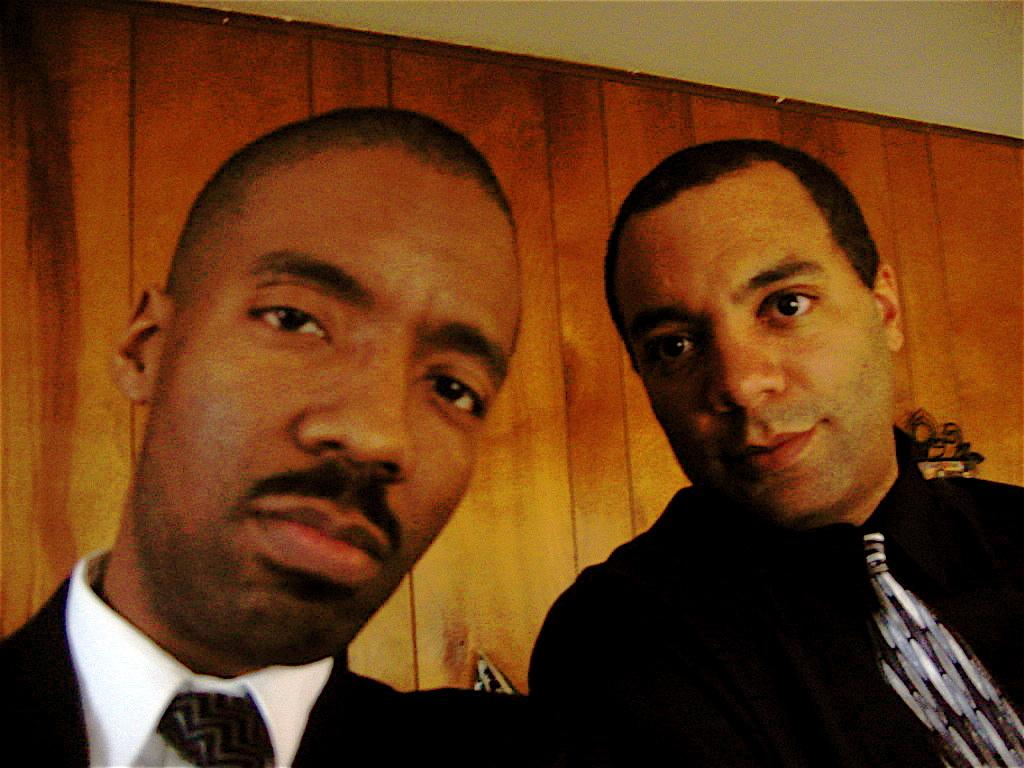How many people are in the image? There are two persons in the image. What can be seen in the background of the image? There is a wooden wall in the background of the image. What part of a building is visible in the image? The roof is visible in the image. What type of butter is being spread on the crackers by the chickens in the image? There are no chickens, butter, or crackers present in the image. 